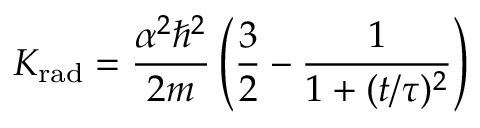Convert formula to latex. <formula><loc_0><loc_0><loc_500><loc_500>K _ { r a d } = { \frac { \alpha ^ { 2 } \hbar { ^ } { 2 } } { 2 m } } \left ( { \frac { 3 } { 2 } } - { \frac { 1 } { 1 + ( t / \tau ) ^ { 2 } } } \right )</formula> 